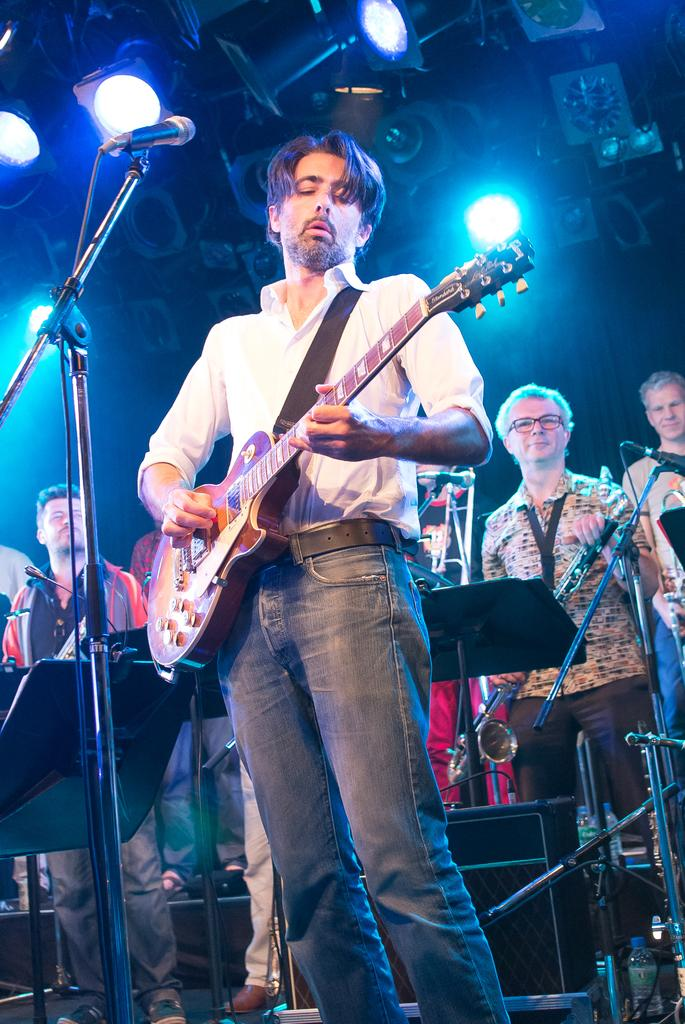What is happening in the image? There are people standing in the image, and one of the men is holding a guitar. What object is in front of the man with the guitar? There is a microphone in front of the man with the guitar. How many bikes are parked next to the man with the guitar in the image? There are no bikes present in the image. What type of tax is being discussed by the people in the image? There is no discussion about taxes in the image. 